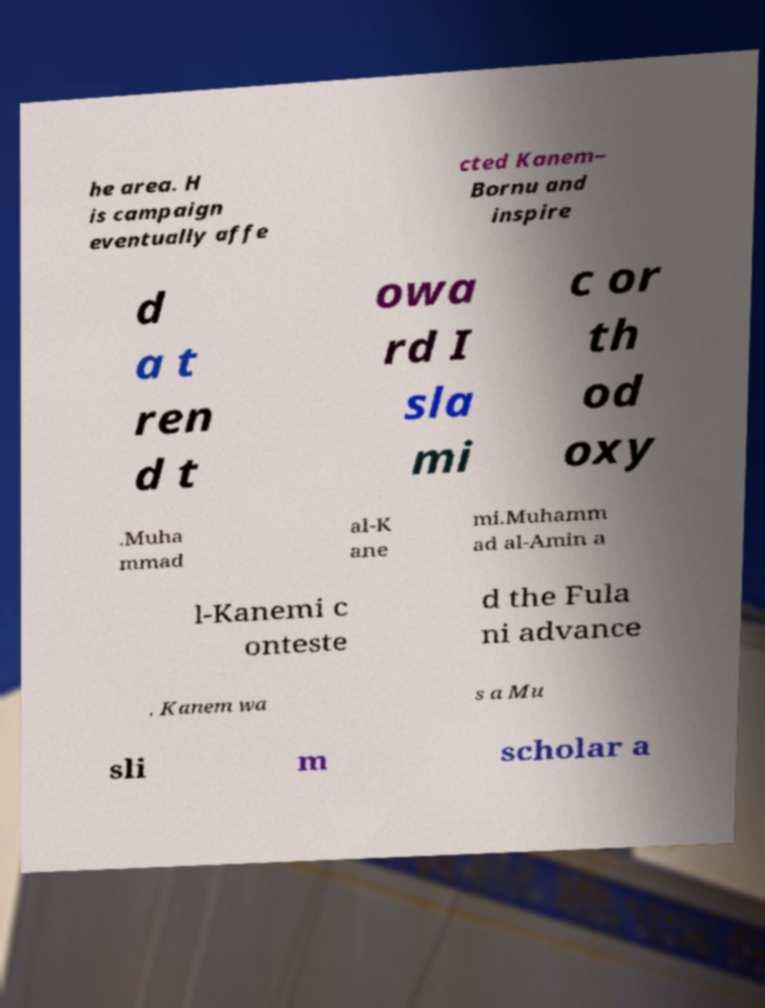There's text embedded in this image that I need extracted. Can you transcribe it verbatim? he area. H is campaign eventually affe cted Kanem– Bornu and inspire d a t ren d t owa rd I sla mi c or th od oxy .Muha mmad al-K ane mi.Muhamm ad al-Amin a l-Kanemi c onteste d the Fula ni advance . Kanem wa s a Mu sli m scholar a 